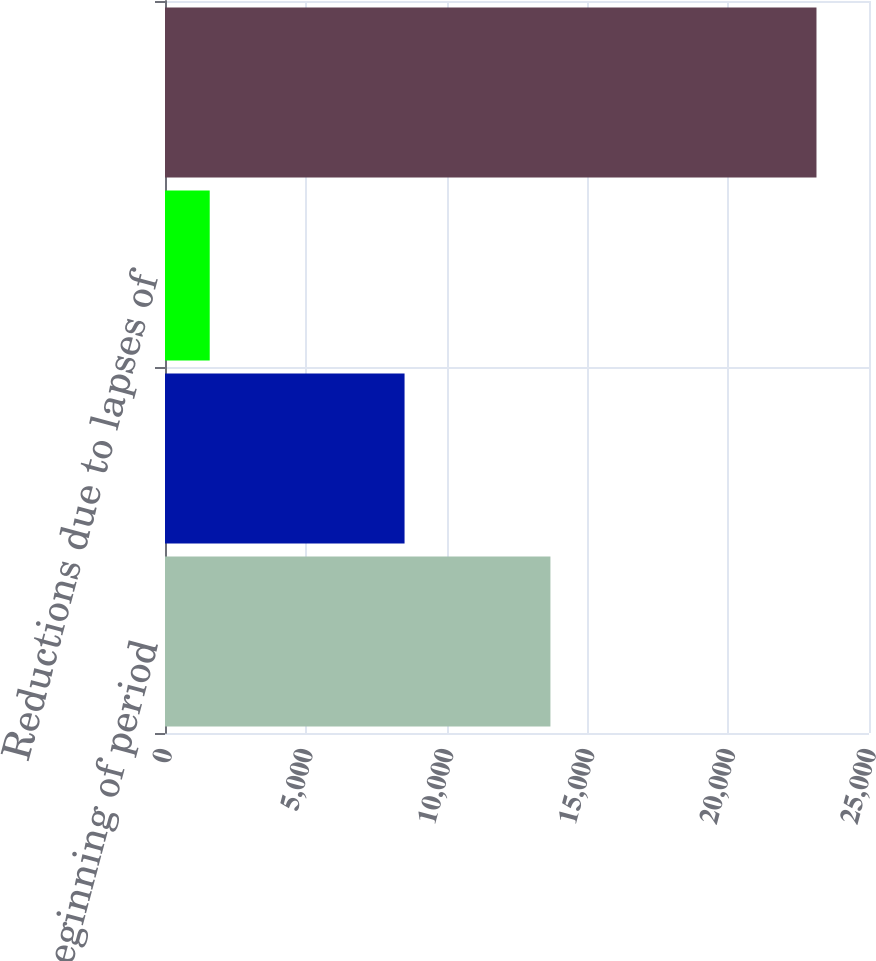Convert chart. <chart><loc_0><loc_0><loc_500><loc_500><bar_chart><fcel>Balance beginning of period<fcel>Gross increases related to<fcel>Reductions due to lapses of<fcel>Balance end of period<nl><fcel>13687<fcel>8507<fcel>1588<fcel>23135<nl></chart> 